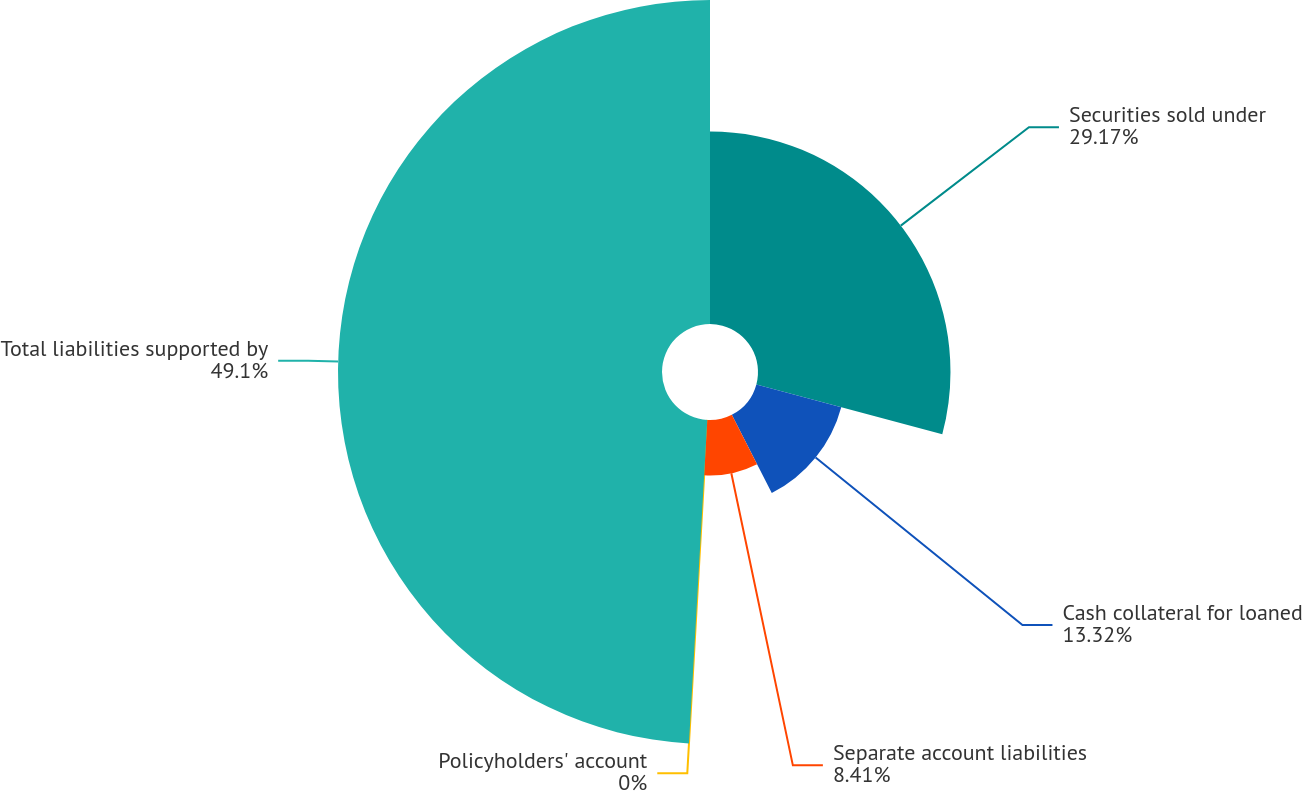Convert chart. <chart><loc_0><loc_0><loc_500><loc_500><pie_chart><fcel>Securities sold under<fcel>Cash collateral for loaned<fcel>Separate account liabilities<fcel>Policyholders' account<fcel>Total liabilities supported by<nl><fcel>29.17%<fcel>13.32%<fcel>8.41%<fcel>0.0%<fcel>49.1%<nl></chart> 